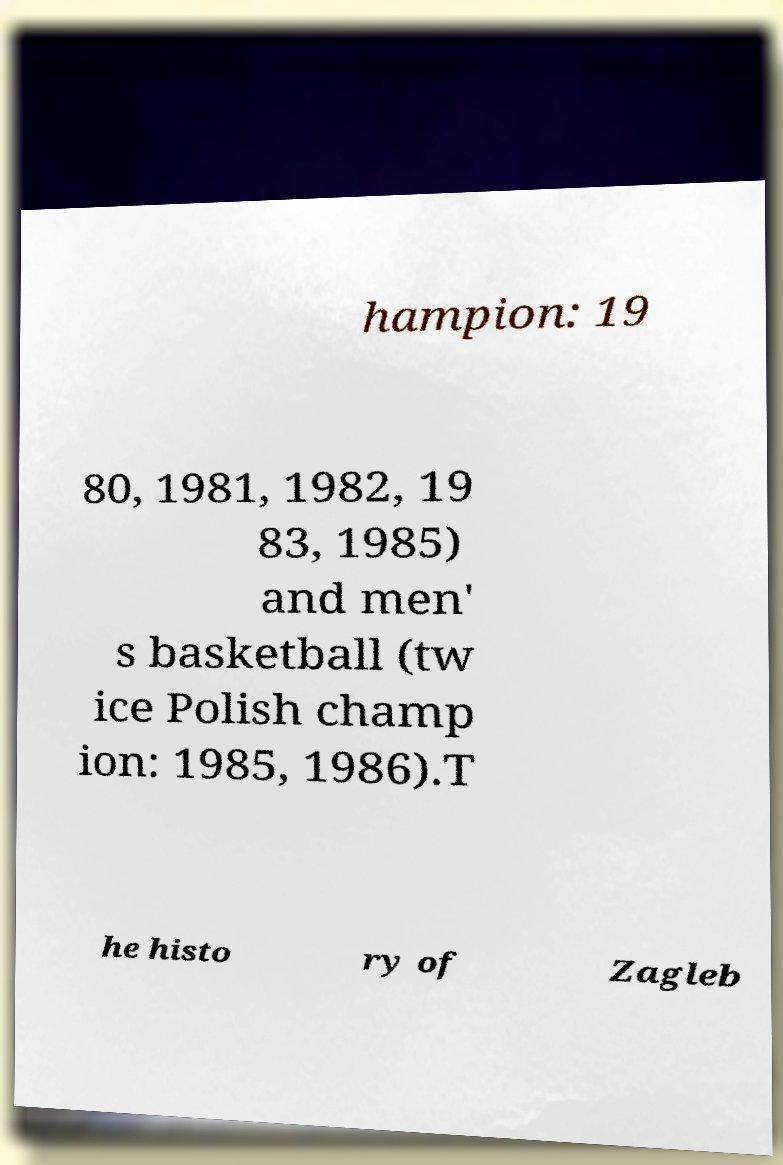Can you accurately transcribe the text from the provided image for me? hampion: 19 80, 1981, 1982, 19 83, 1985) and men' s basketball (tw ice Polish champ ion: 1985, 1986).T he histo ry of Zagleb 